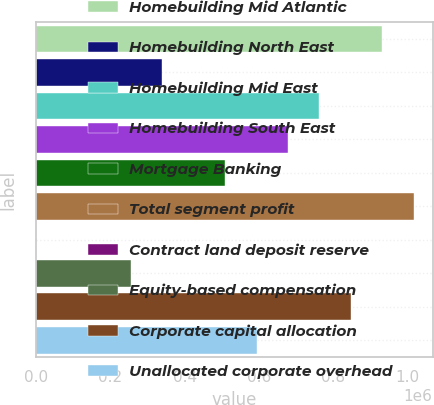<chart> <loc_0><loc_0><loc_500><loc_500><bar_chart><fcel>Homebuilding Mid Atlantic<fcel>Homebuilding North East<fcel>Homebuilding Mid East<fcel>Homebuilding South East<fcel>Mortgage Banking<fcel>Total segment profit<fcel>Contract land deposit reserve<fcel>Equity-based compensation<fcel>Corporate capital allocation<fcel>Unallocated corporate overhead<nl><fcel>931471<fcel>339549<fcel>762351<fcel>677790<fcel>508669<fcel>1.01603e+06<fcel>1307<fcel>254988<fcel>846911<fcel>593230<nl></chart> 